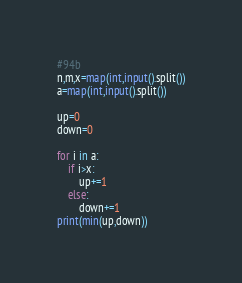<code> <loc_0><loc_0><loc_500><loc_500><_Python_>#94b
n,m,x=map(int,input().split())
a=map(int,input().split())

up=0
down=0

for i in a:
    if i>x:
        up+=1
    else:
        down+=1
print(min(up,down))</code> 